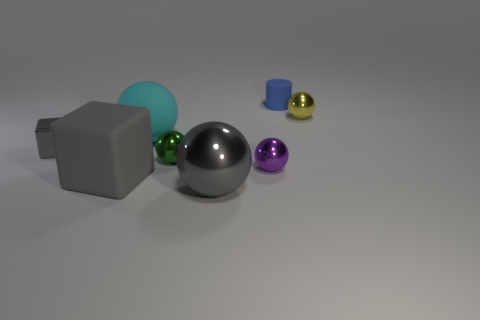How many things are small metal things that are to the left of the large matte sphere or big green things?
Offer a very short reply. 1. What material is the large sphere that is the same color as the tiny cube?
Give a very brief answer. Metal. There is a large gray thing that is behind the gray metallic object right of the cyan matte sphere; is there a object behind it?
Offer a terse response. Yes. Are there fewer matte objects right of the small yellow object than gray things that are behind the purple shiny object?
Give a very brief answer. Yes. The block that is made of the same material as the small blue object is what color?
Provide a short and direct response. Gray. What is the color of the tiny metallic ball that is on the left side of the big gray object to the right of the green shiny object?
Your answer should be compact. Green. Are there any big metallic spheres that have the same color as the large rubber ball?
Your answer should be very brief. No. The purple metal object that is the same size as the blue object is what shape?
Provide a succinct answer. Sphere. How many big gray spheres are right of the gray block that is right of the tiny gray object?
Your response must be concise. 1. Do the big cube and the large shiny thing have the same color?
Give a very brief answer. Yes. 